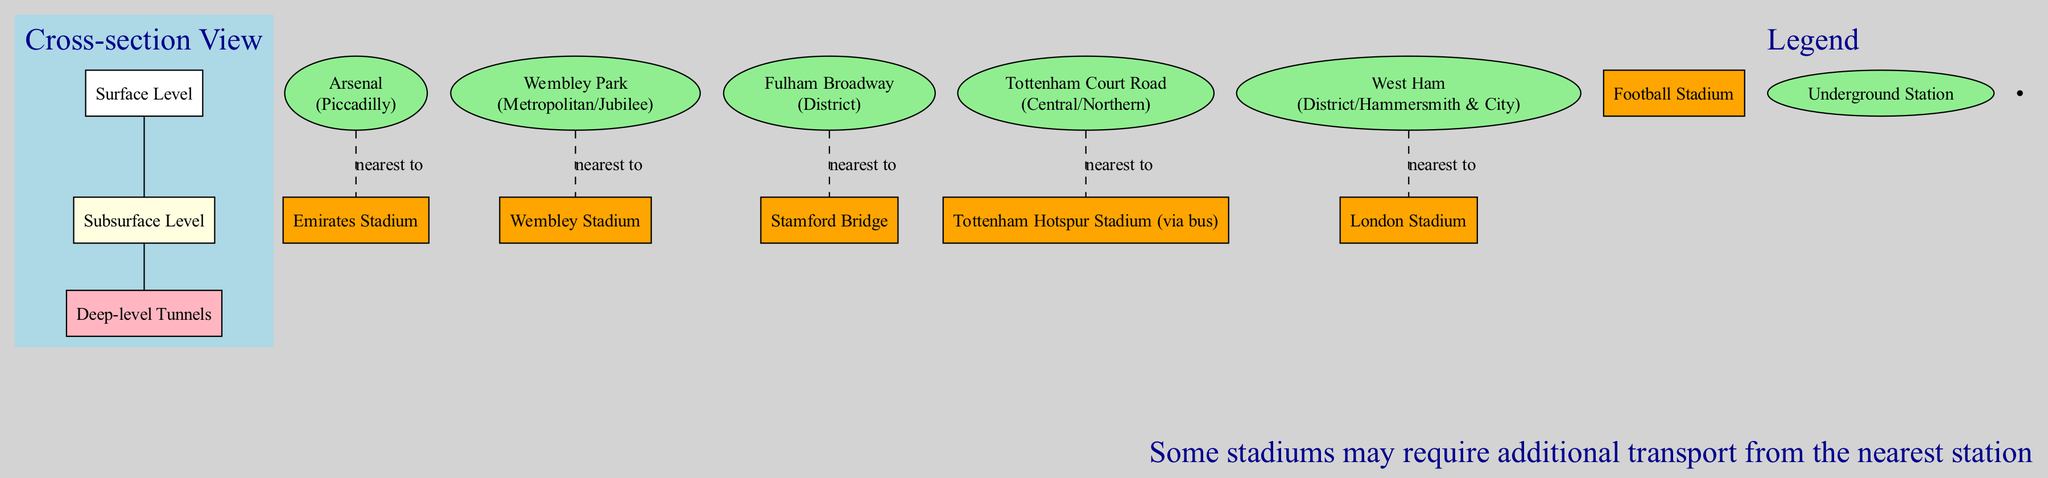What is the nearest stadium to the Arsenal station? Arsenal station is connected to the Emirates Stadium, indicated by the dashed line in the diagram.
Answer: Emirates Stadium How many levels are depicted in the cross-section view? The diagram shows three distinct levels: Surface Level, Subsurface Level, and Deep-level Tunnels.
Answer: Three Which Underground line services the Wembley Park station? The diagram clearly states that Wembley Park station is serviced by the Metropolitan and Jubilee lines, shown next to the station name.
Answer: Metropolitan/Jubilee What color represents the Underground stations in the diagram? Underground stations are represented in light green, as indicated by the color coding of the nodes in the diagram.
Answer: Light green Which stadium requires additional transport from its nearest station according to the note? The note specifies that Tottenham Hotspur Stadium may require additional transport from Tottenham Court Road station, as it's not directly linked.
Answer: Tottenham Hotspur Stadium How many key stations are listed in the diagram? By counting the number of individual stations shown in the key stations section of the diagram, we find a total of five key stations.
Answer: Five What shape is used to represent football stadiums in the diagram? The football stadiums are represented as rectangles, indicated by their distinct shape and color in the legend section of the diagram.
Answer: Rectangle Which station has the nearest stadium as Stamford Bridge? The Fulham Broadway station is connected to Stamford Bridge, as denoted by the dashed connection line leading from the station to the stadium.
Answer: Fulham Broadway What type of diagram is represented in this illustration? This illustration is a textbook diagram, specifically a cross-section view of the London Underground system, as mentioned in the title.
Answer: Textbook diagram 